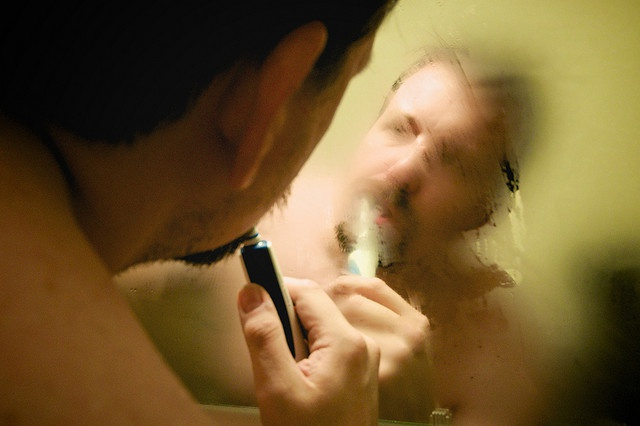Describe the objects in this image and their specific colors. I can see people in black, maroon, and brown tones, people in black, olive, maroon, and tan tones, toothbrush in black, brown, olive, and tan tones, and toothbrush in black, khaki, beige, and tan tones in this image. 